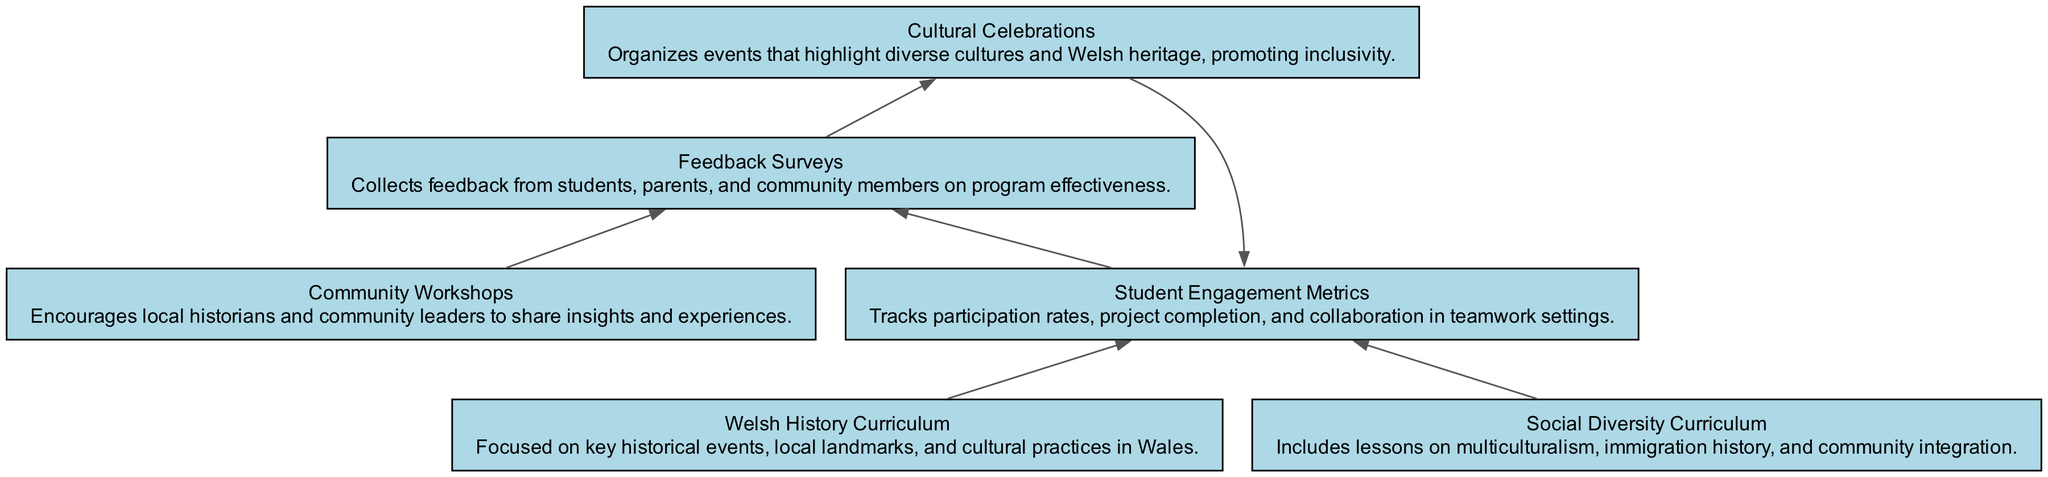What are two components of the curriculum? The diagram shows two main curriculum components: "Welsh History Curriculum" and "Social Diversity Curriculum." These nodes are depicted separately, emphasizing their distinct focuses within the educational programs.
Answer: Welsh History Curriculum, Social Diversity Curriculum How many total nodes are in the diagram? By counting the individual elements represented in the diagram, we can identify that there are six nodes: the two curriculum components, the student engagement metrics, the community workshops, the feedback surveys, and the cultural celebrations.
Answer: 6 What do feedback surveys collect? The description for the "Feedback Surveys" node states that they collect feedback from students, parents, and community members. This indicates the gathering of opinions regarding the effectiveness of the educational programs.
Answer: Feedback from students, parents, and community members Which node receives input from both curriculum components? The "Student Engagement Metrics" node receives input from both the "Welsh History Curriculum" and the "Social Diversity Curriculum." The diagram specifies direct edges from these two nodes leading to "Student Engagement Metrics."
Answer: Student Engagement Metrics What do community workshops aim to encourage? The "Community Workshops" node describes their aim to encourage local historians and community leaders to share insights and experiences. Thus, the intention is to foster dialogue and understanding among diverse community members.
Answer: Local historians and community leaders to share insights and experiences Which node sends feedback to cultural celebrations? The "Feedback Surveys" node sends feedback to the "Cultural Celebrations" node. This is evident from the directed edge connecting these two nodes in the flowchart, indicating that input via feedback is used to inform cultural events.
Answer: Cultural Celebrations How do cultural celebrations influence student engagement metrics? The "Cultural Celebrations" node influences the "Student Engagement Metrics" through feedback on these events, which helps assess and potentially increase participation and collaboration among students in the educational programs.
Answer: Student Engagement Metrics What is the purpose of tracking student engagement metrics? The purpose of tracking "Student Engagement Metrics" is to monitor participation rates, project completion, and teamwork collaboration in the educational programs, ultimately evaluating their success and areas for improvement.
Answer: Monitor participation rates, project completion, and collaboration 